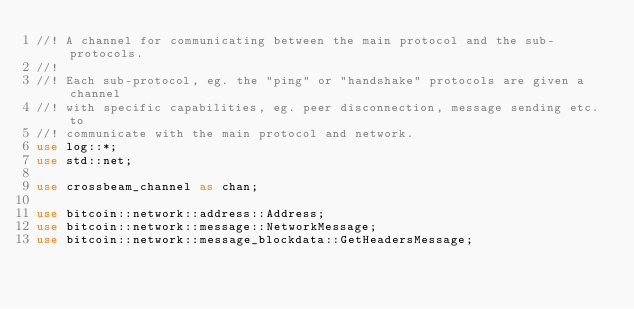<code> <loc_0><loc_0><loc_500><loc_500><_Rust_>//! A channel for communicating between the main protocol and the sub-protocols.
//!
//! Each sub-protocol, eg. the "ping" or "handshake" protocols are given a channel
//! with specific capabilities, eg. peer disconnection, message sending etc. to
//! communicate with the main protocol and network.
use log::*;
use std::net;

use crossbeam_channel as chan;

use bitcoin::network::address::Address;
use bitcoin::network::message::NetworkMessage;
use bitcoin::network::message_blockdata::GetHeadersMessage;</code> 